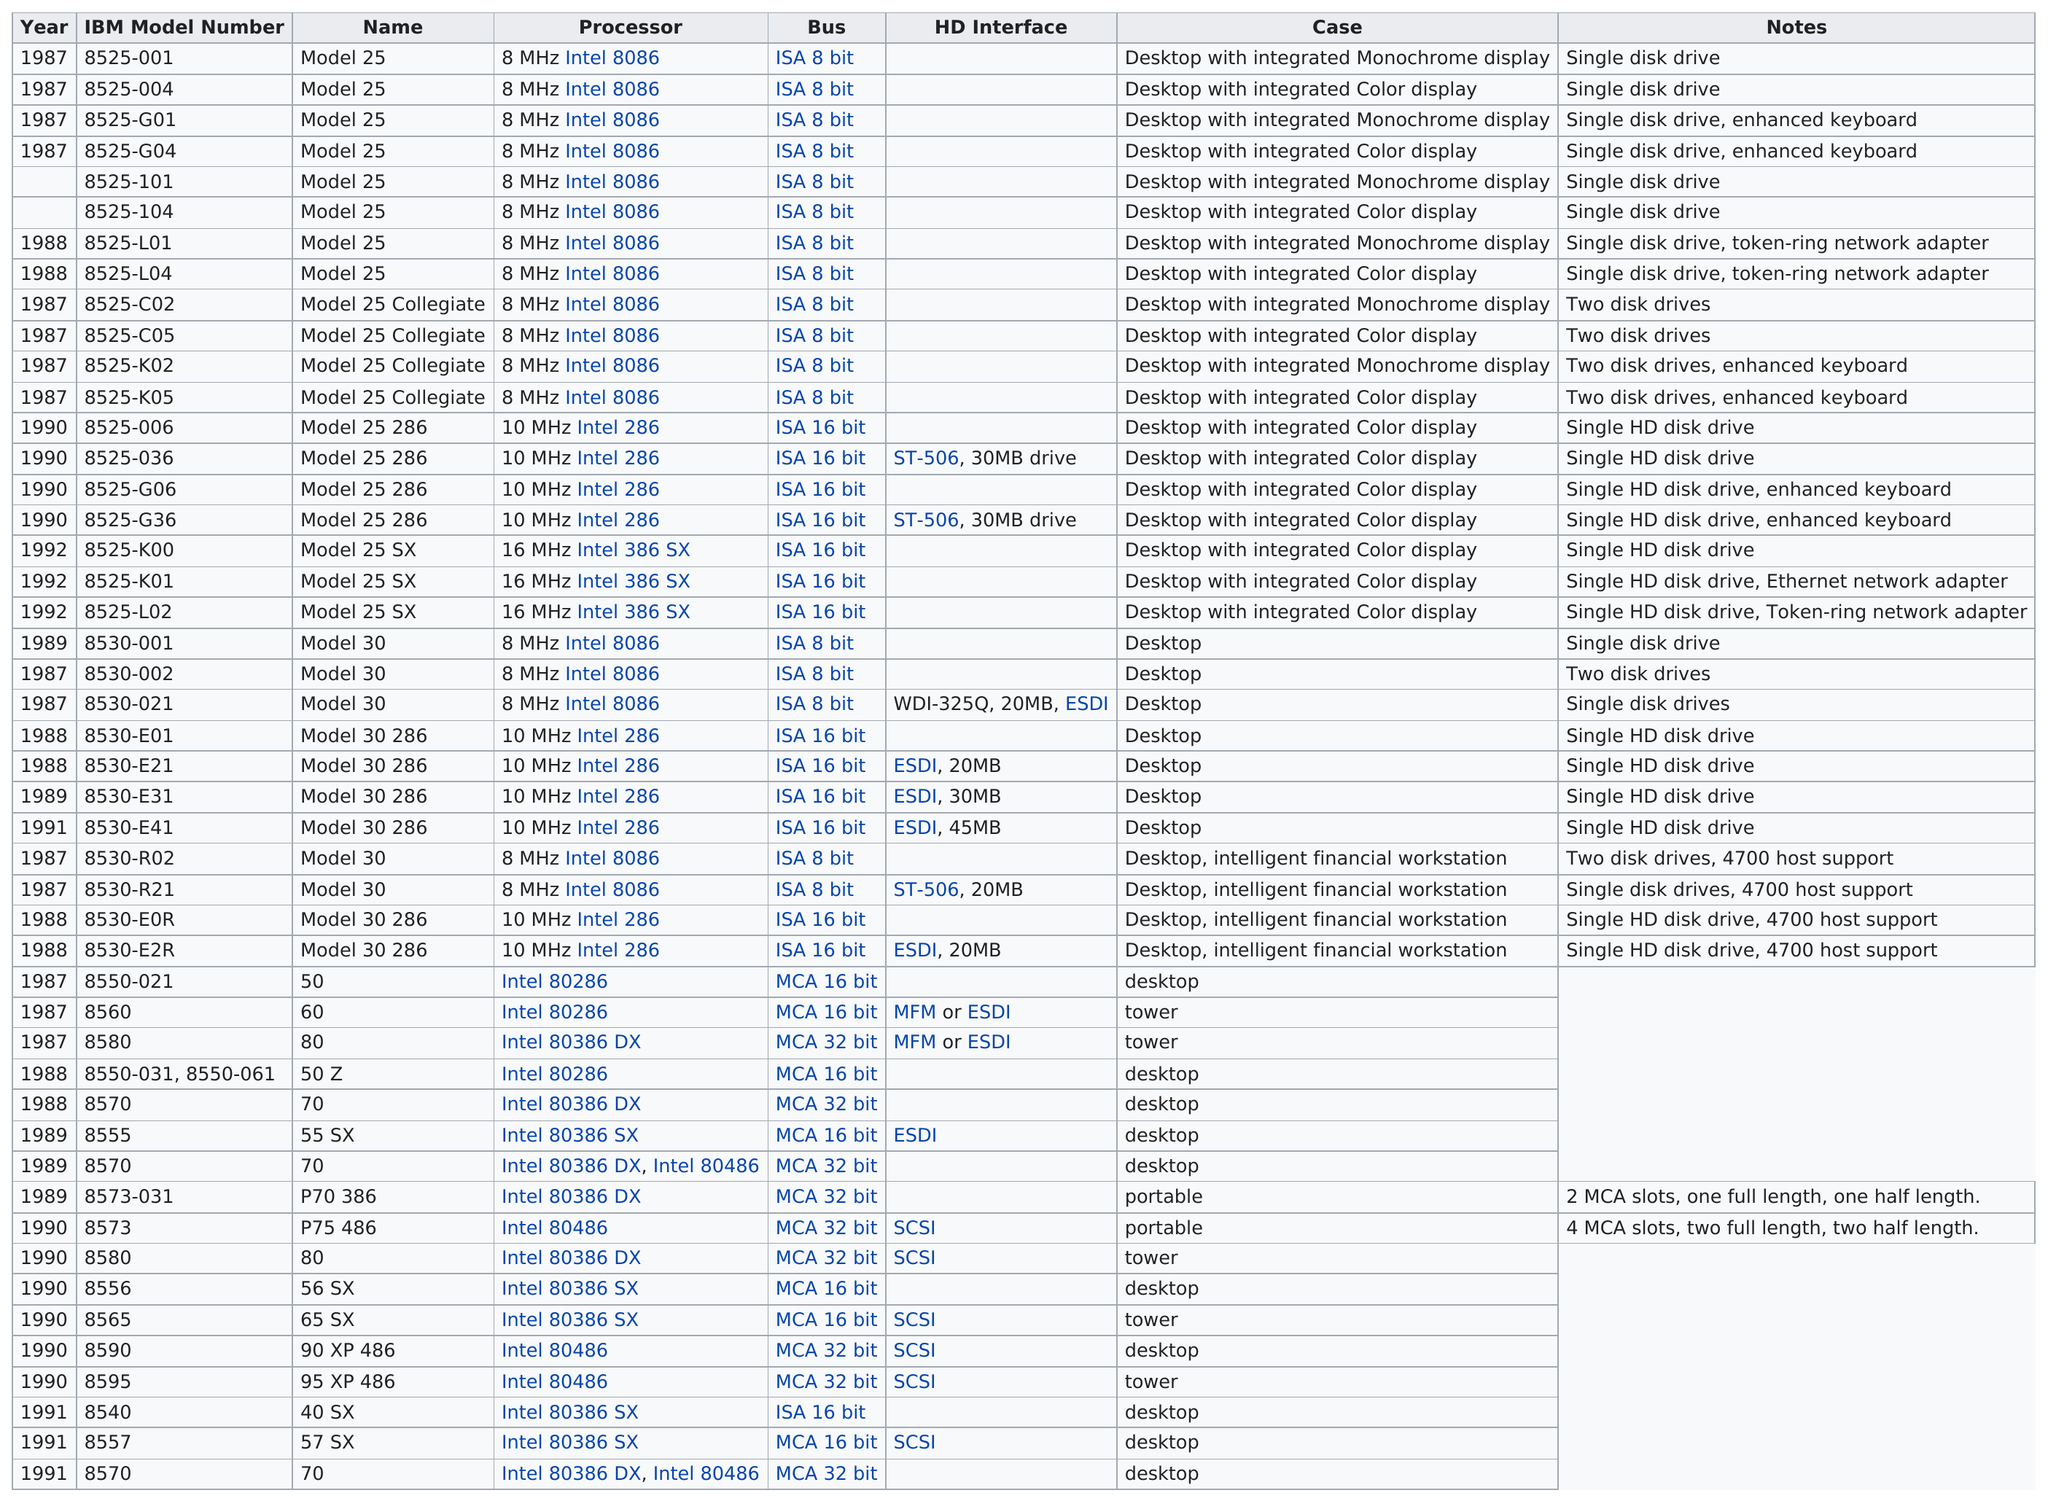Identify some key points in this picture. There are a total of 4 processors that have both an integrated color display and an enhanced keyboard. The next model number listed after 8525-L01 is 8525-L04. The chart lists Model 25 a total of 8 times. What is the name of the last model listed on this chart?" is a question that requires a response to be provided. The response to this question would be "The last model listed on this chart is XYZ. The IBM 8525-001 processor speed is below 10 MHz. 